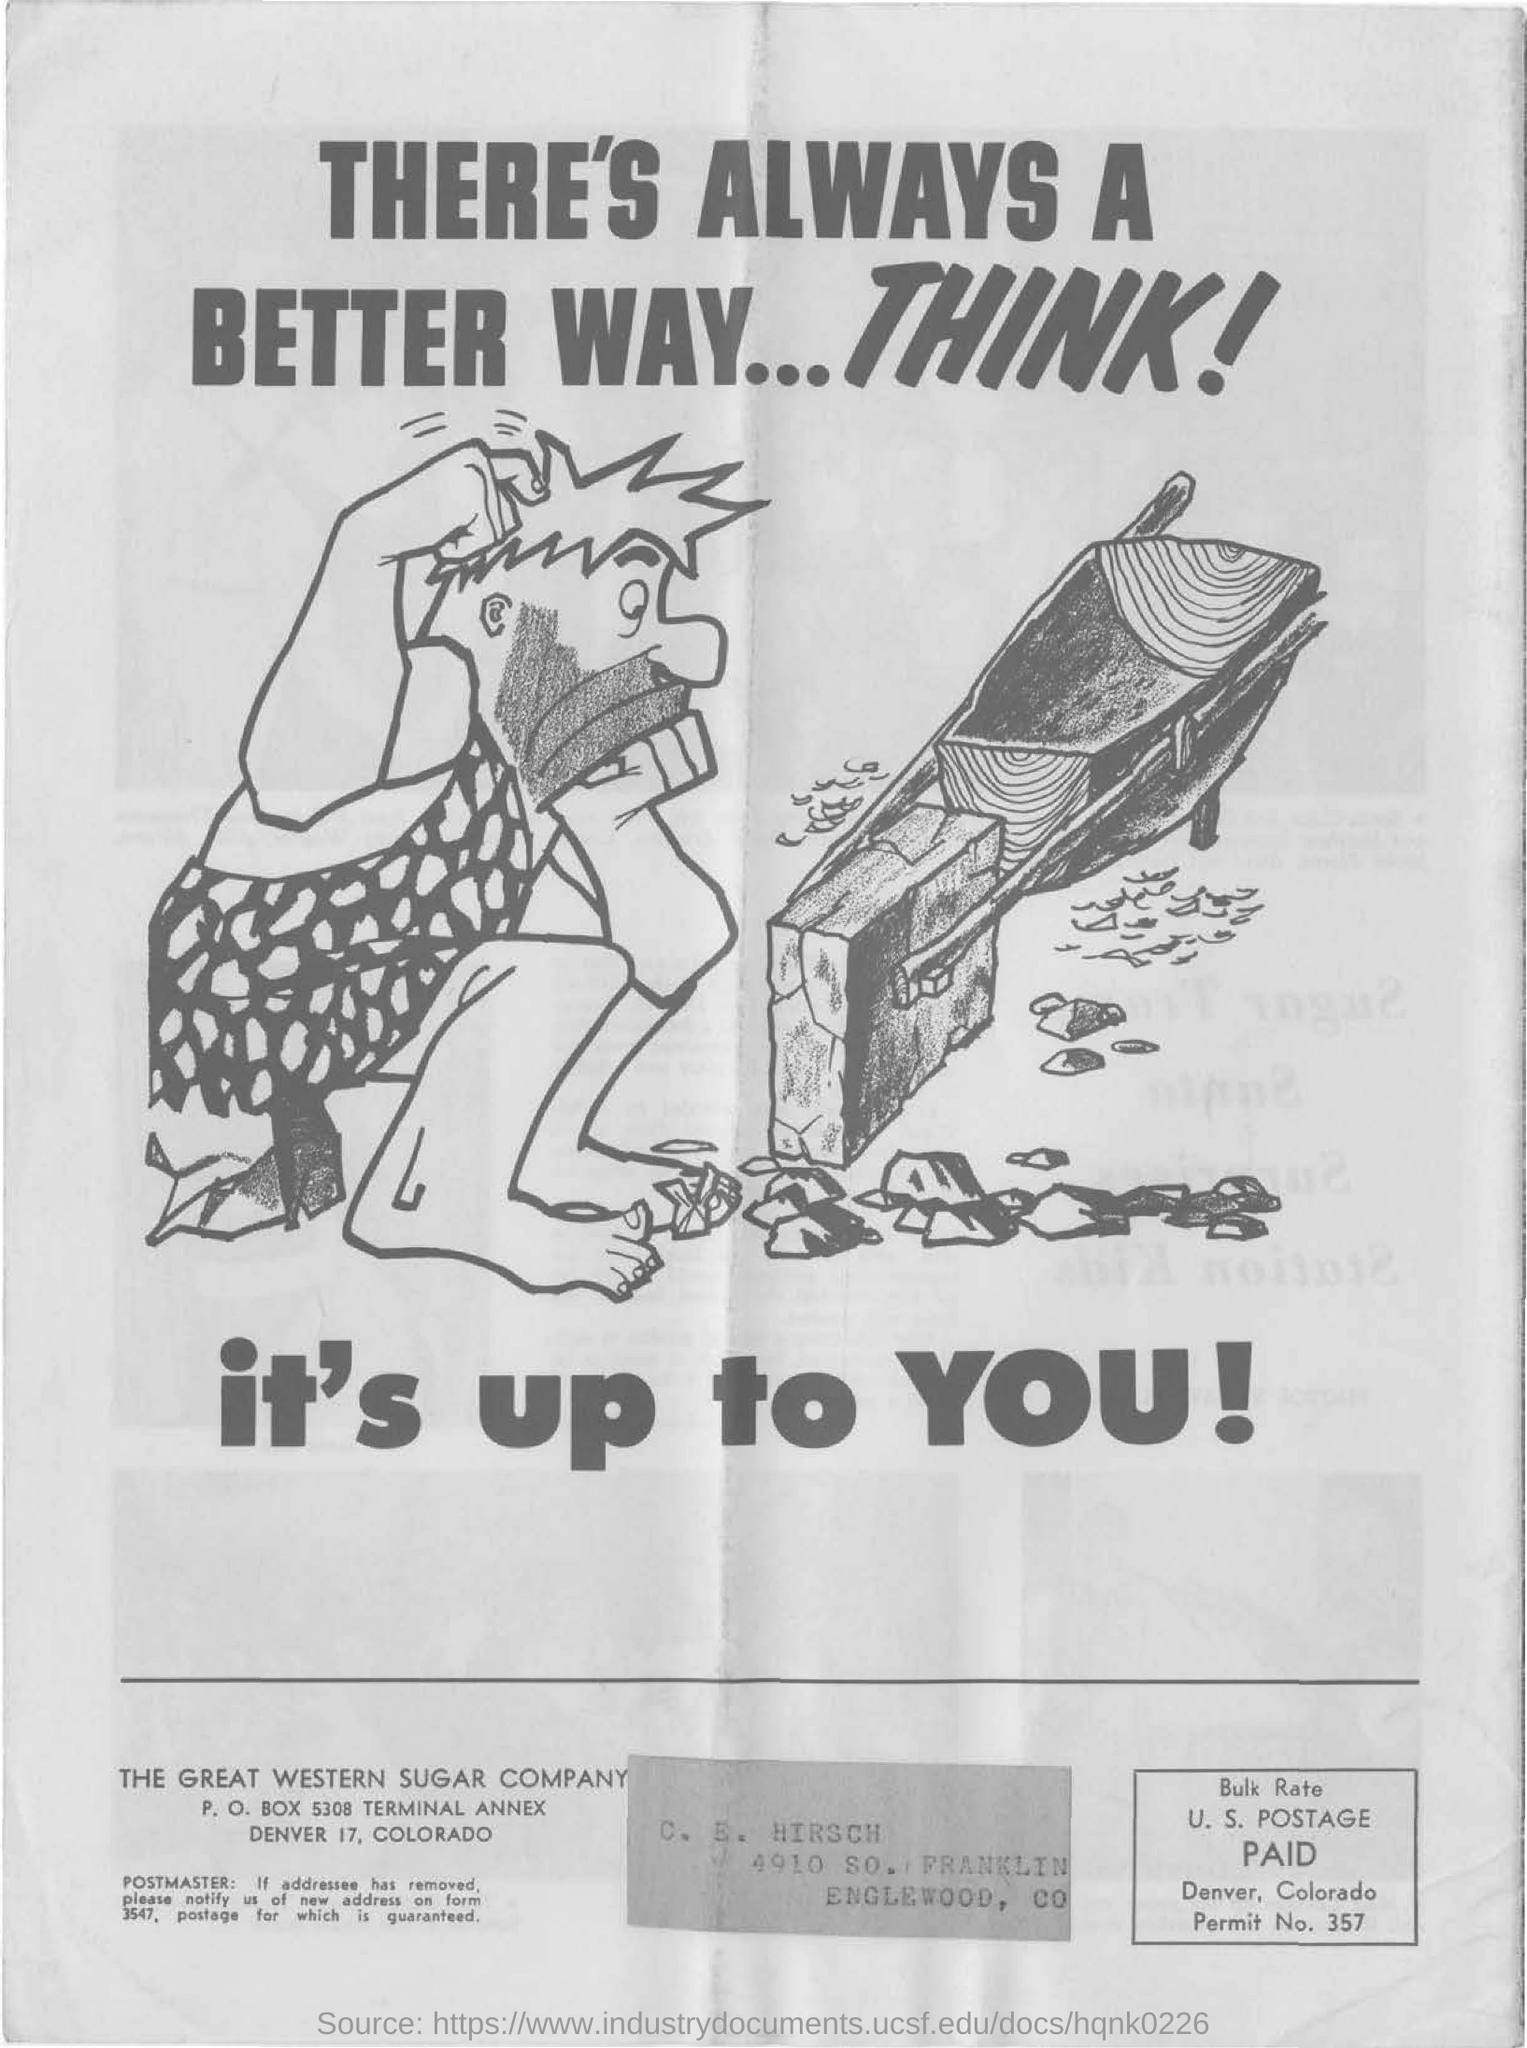What is the name of the company mentioned at the bottom?
Give a very brief answer. The great western sugar company. What is the p. o. box of the great western sugar company?
Your answer should be very brief. 5308. What does the image say?
Provide a succinct answer. THERE'S ALWAYS A BETTER WAY...THINK!. 